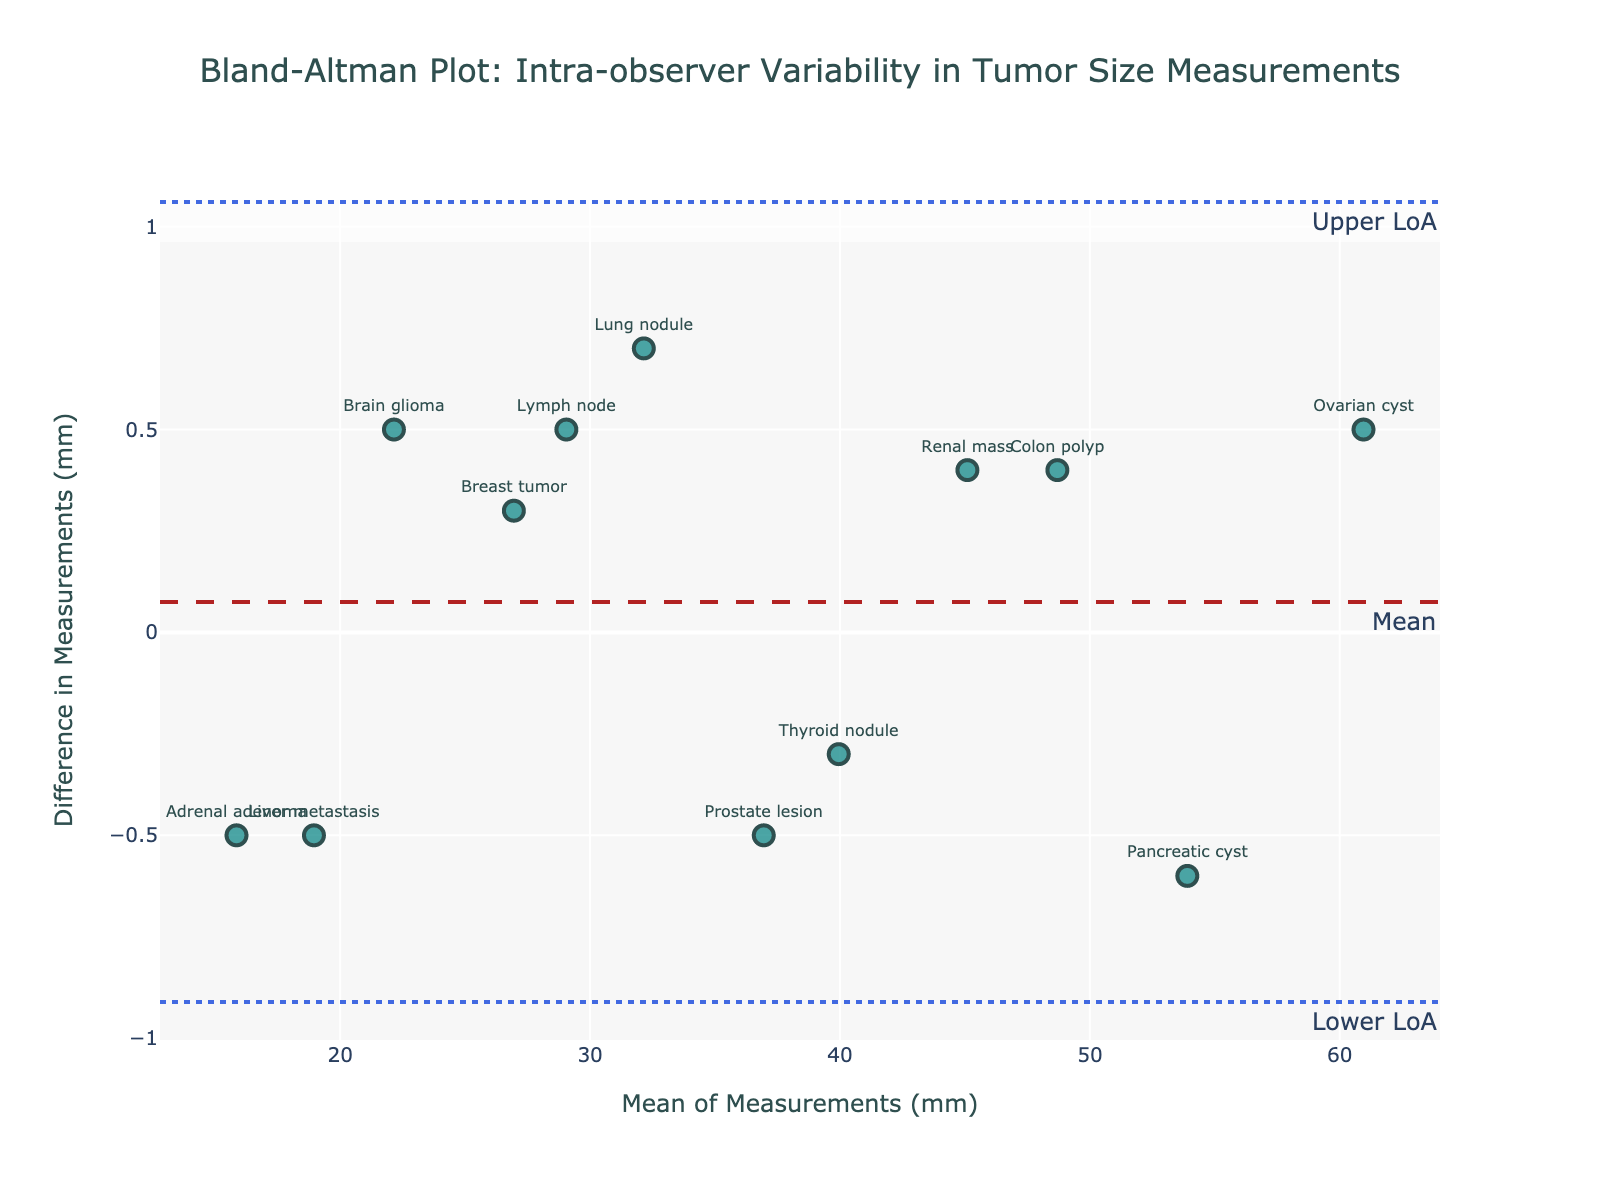what is the title of the plot? The title is displayed at the top of the figure. You can read it directly from the visual.
Answer: Bland-Altman Plot: Intra-observer Variability in Tumor Size Measurements How many data points are plotted in the figure? Each data point corresponds to a tumor type, and there are individual markers for each. You can count the number of markers on the plot.
Answer: 12 What is the mean difference indicated by the dashed line? The dashed line represents the mean difference, having a label indicating "Mean." Read the y-axis value at this line.
Answer: -0.1 What are the upper and lower limits of agreement? The limits of agreement are represented by dotted lines labeled "Lower LoA" and "Upper LoA." Read the y-axis values at these points.
Answer: Lower LoA: -1.8, Upper LoA: 1.6 Which tumor type has the largest mean of measurements? The tumor type with the largest mean of measurements can be identified by locating the data point farthest right on the x-axis. The hover text for each marker shows the tumor type and mean.
Answer: Ovarian cyst What is the difference for the pancreatic cyst measurement? Locate the data point labeled "Pancreatic cyst," and read the difference value either from the marker directly or from the hover text.
Answer: -0.6 Compare the differences between the lung nodule and colon polyp. Which one is greater? Find the data points for "Lung nodule" and "Colon polyp," then compare their y-axis positions (difference values). The one higher on the y-axis has a greater difference.
Answer: Lung nodule Which measurement has the smallest difference? Identify the data point closest to the baseline (mean difference line) on the y-axis, as it represents the smallest absolute difference.
Answer: Thyroid nodule How much larger is the difference in prostate lesion measurements compared to brain glioma? Find the differences for "Prostate lesion" and "Brain glioma." Calculate the difference by subtracting the brain glioma's difference from the prostate lesion's.
Answer: 1.5 Does the data show a trend of increasing or decreasing difference with increasing mean measurement? Assess the general distribution of data points. If there's a noticeable incline or decline from left to right, it suggests a trend.
Answer: No notable trend 